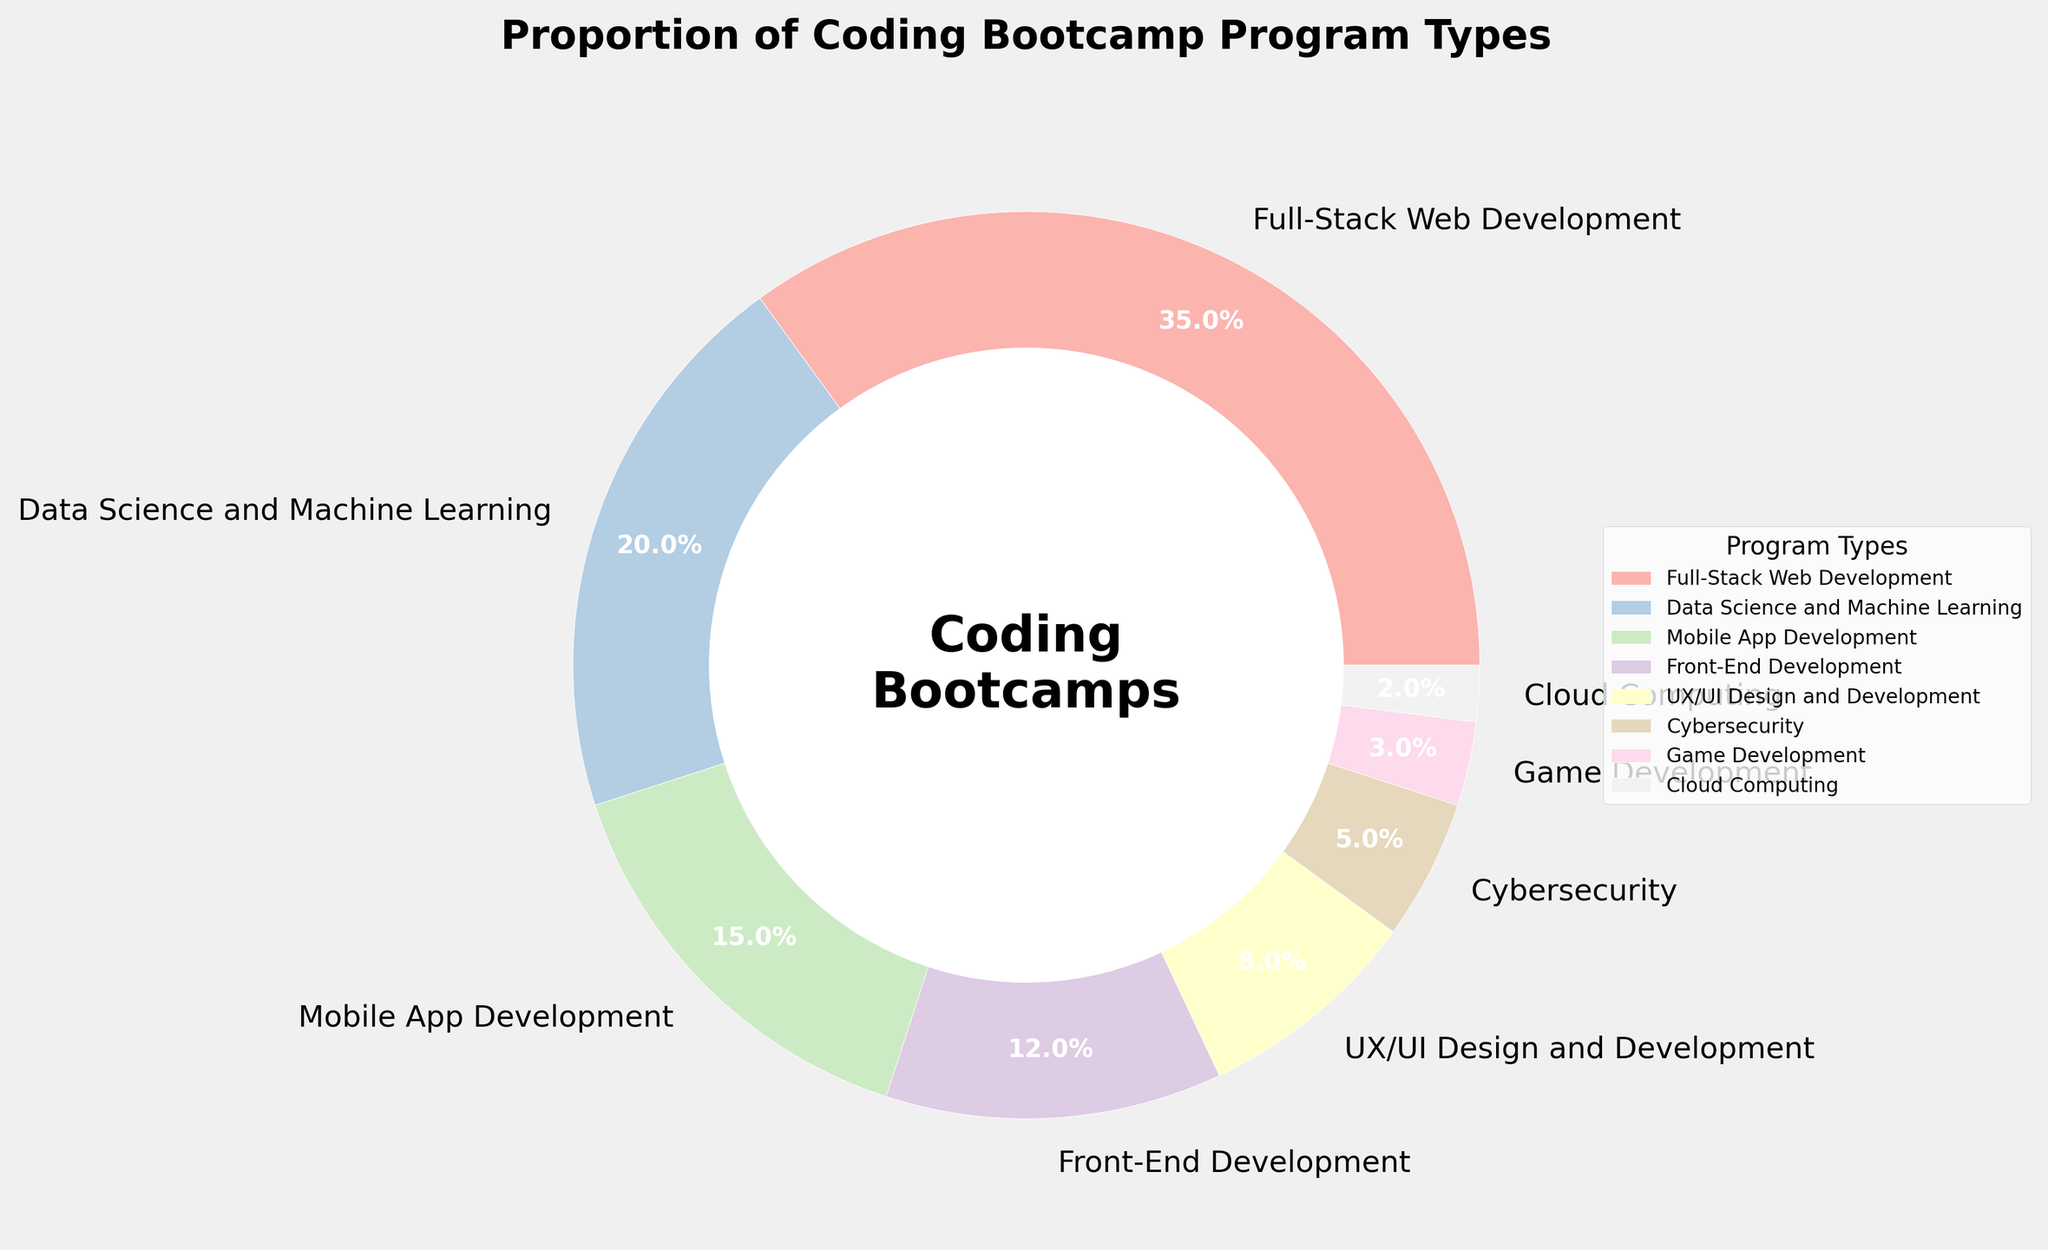What's the largest program type by percentage? The largest section in the pie chart represents Full-Stack Web Development. By observing the chart, we can see that it occupies the most space and is labeled with the highest percentage, which is 35%.
Answer: Full-Stack Web Development Which program type is the smallest by percentage? The smallest section in the pie chart corresponds to Cloud Computing. By examining the chart, we can see that this segment occupies the least space, labeled with the smallest percentage, which is 2%.
Answer: Cloud Computing What is the combined percentage of Mobile App Development and Front-End Development? To find the combined percentage, sum the percentages of Mobile App Development (15%) and Front-End Development (12%). The combined percentage is 15% + 12% = 27%.
Answer: 27% Are there more programs focusing on design (UX/UI Design and Development) or security (Cybersecurity)? By comparing the percentages, UX/UI Design and Development has 8% while Cybersecurity has 5%. Since 8% is greater than 5%, there are more programs focusing on design than security.
Answer: Design (UX/UI Design and Development) What is the difference in percentage between Data Science and Machine Learning and Game Development? To find the difference, subtract the percentage of Game Development (3%) from the percentage of Data Science and Machine Learning (20%). The difference is 20% - 3% = 17%.
Answer: 17% Which program types collectively form more than half of the total percentage? To determine which program types collectively exceed 50%, start adding the largest percentages: Full-Stack Web Development (35%) + Data Science and Machine Learning (20%) = 55%. These two program types together already exceed 50%.
Answer: Full-Stack Web Development and Data Science and Machine Learning How many program types have a percentage greater than 10%? By scanning the pie chart, the program types with percentages greater than 10% are Full-Stack Web Development (35%), Data Science and Machine Learning (20%), Mobile App Development (15%), and Front-End Development (12%). There are 4 such program types.
Answer: 4 What's the percentage difference between the largest and smallest program types? The largest program type is Full-Stack Web Development at 35%, and the smallest is Cloud Computing at 2%. The difference is 35% - 2% = 33%.
Answer: 33% If UX/UI Design and Development and Cybersecurity are combined, do they have a higher percentage than Mobile App Development? Combine the percentages of UX/UI Design and Development (8%) and Cybersecurity (5%): 8% + 5% = 13%. Compare this to Mobile App Development which is 15%. Since 13% is less than 15%, they collectively have a lower percentage.
Answer: No 